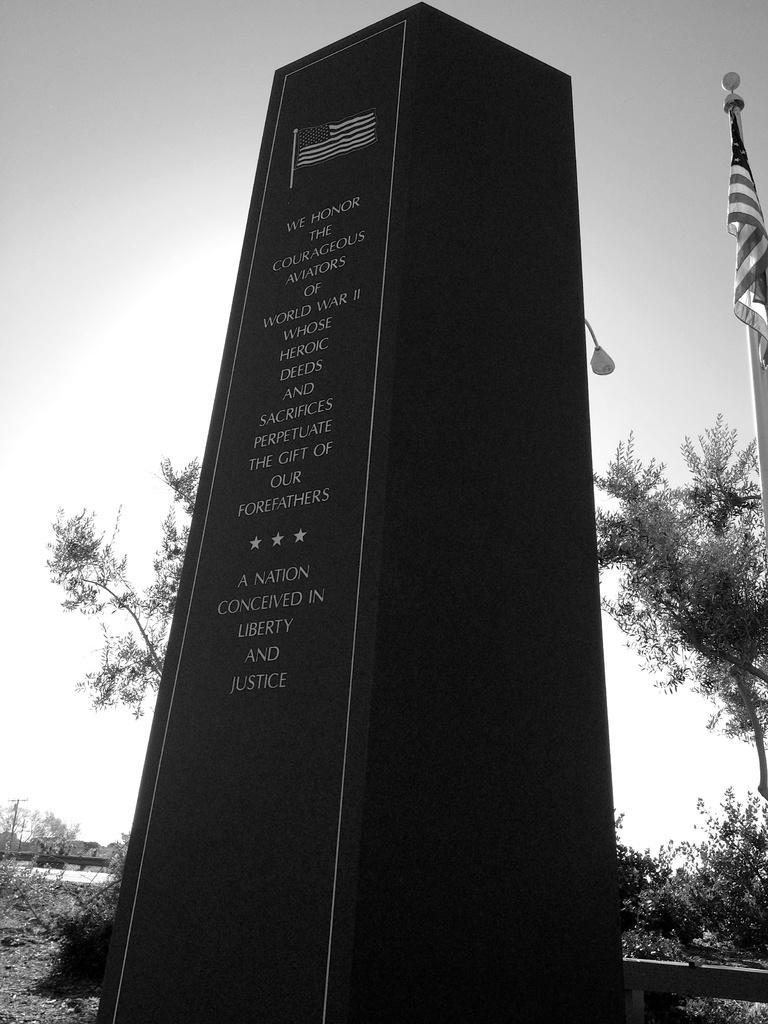Could you give a brief overview of what you see in this image? This is a black and white image. In this image I can see a memorial on which there is some text. In the background there are plants and trees. On the right side there is a flag. At the top of the image I can see the sky. 